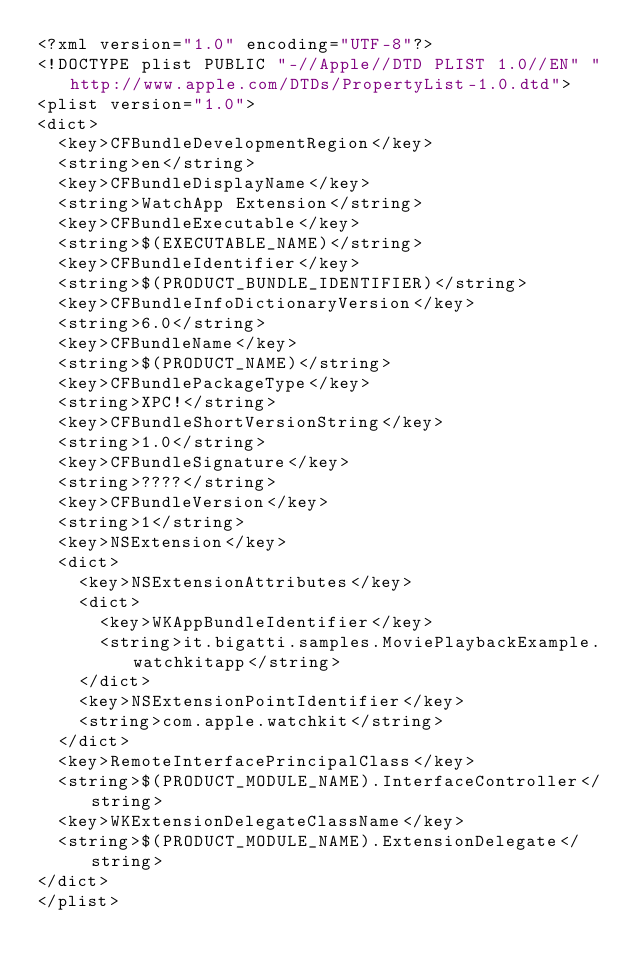<code> <loc_0><loc_0><loc_500><loc_500><_XML_><?xml version="1.0" encoding="UTF-8"?>
<!DOCTYPE plist PUBLIC "-//Apple//DTD PLIST 1.0//EN" "http://www.apple.com/DTDs/PropertyList-1.0.dtd">
<plist version="1.0">
<dict>
	<key>CFBundleDevelopmentRegion</key>
	<string>en</string>
	<key>CFBundleDisplayName</key>
	<string>WatchApp Extension</string>
	<key>CFBundleExecutable</key>
	<string>$(EXECUTABLE_NAME)</string>
	<key>CFBundleIdentifier</key>
	<string>$(PRODUCT_BUNDLE_IDENTIFIER)</string>
	<key>CFBundleInfoDictionaryVersion</key>
	<string>6.0</string>
	<key>CFBundleName</key>
	<string>$(PRODUCT_NAME)</string>
	<key>CFBundlePackageType</key>
	<string>XPC!</string>
	<key>CFBundleShortVersionString</key>
	<string>1.0</string>
	<key>CFBundleSignature</key>
	<string>????</string>
	<key>CFBundleVersion</key>
	<string>1</string>
	<key>NSExtension</key>
	<dict>
		<key>NSExtensionAttributes</key>
		<dict>
			<key>WKAppBundleIdentifier</key>
			<string>it.bigatti.samples.MoviePlaybackExample.watchkitapp</string>
		</dict>
		<key>NSExtensionPointIdentifier</key>
		<string>com.apple.watchkit</string>
	</dict>
	<key>RemoteInterfacePrincipalClass</key>
	<string>$(PRODUCT_MODULE_NAME).InterfaceController</string>
	<key>WKExtensionDelegateClassName</key>
	<string>$(PRODUCT_MODULE_NAME).ExtensionDelegate</string>
</dict>
</plist>
</code> 